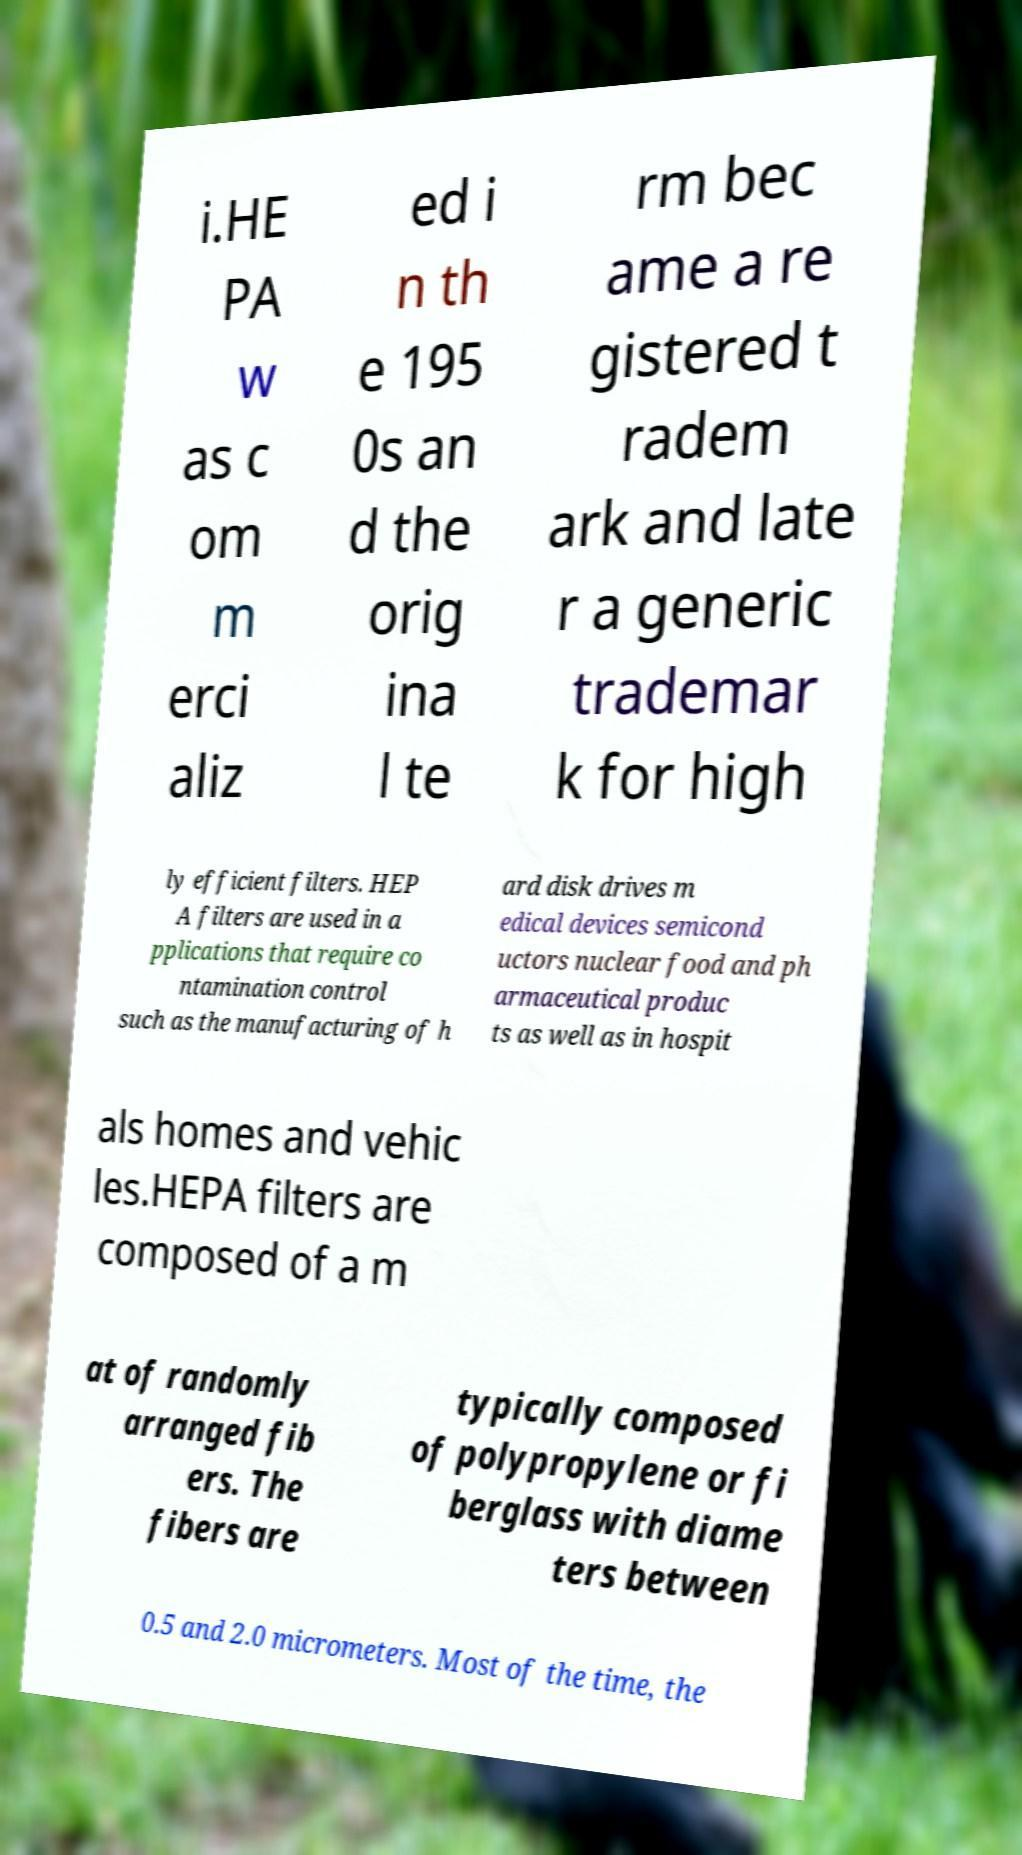Can you read and provide the text displayed in the image?This photo seems to have some interesting text. Can you extract and type it out for me? i.HE PA w as c om m erci aliz ed i n th e 195 0s an d the orig ina l te rm bec ame a re gistered t radem ark and late r a generic trademar k for high ly efficient filters. HEP A filters are used in a pplications that require co ntamination control such as the manufacturing of h ard disk drives m edical devices semicond uctors nuclear food and ph armaceutical produc ts as well as in hospit als homes and vehic les.HEPA filters are composed of a m at of randomly arranged fib ers. The fibers are typically composed of polypropylene or fi berglass with diame ters between 0.5 and 2.0 micrometers. Most of the time, the 